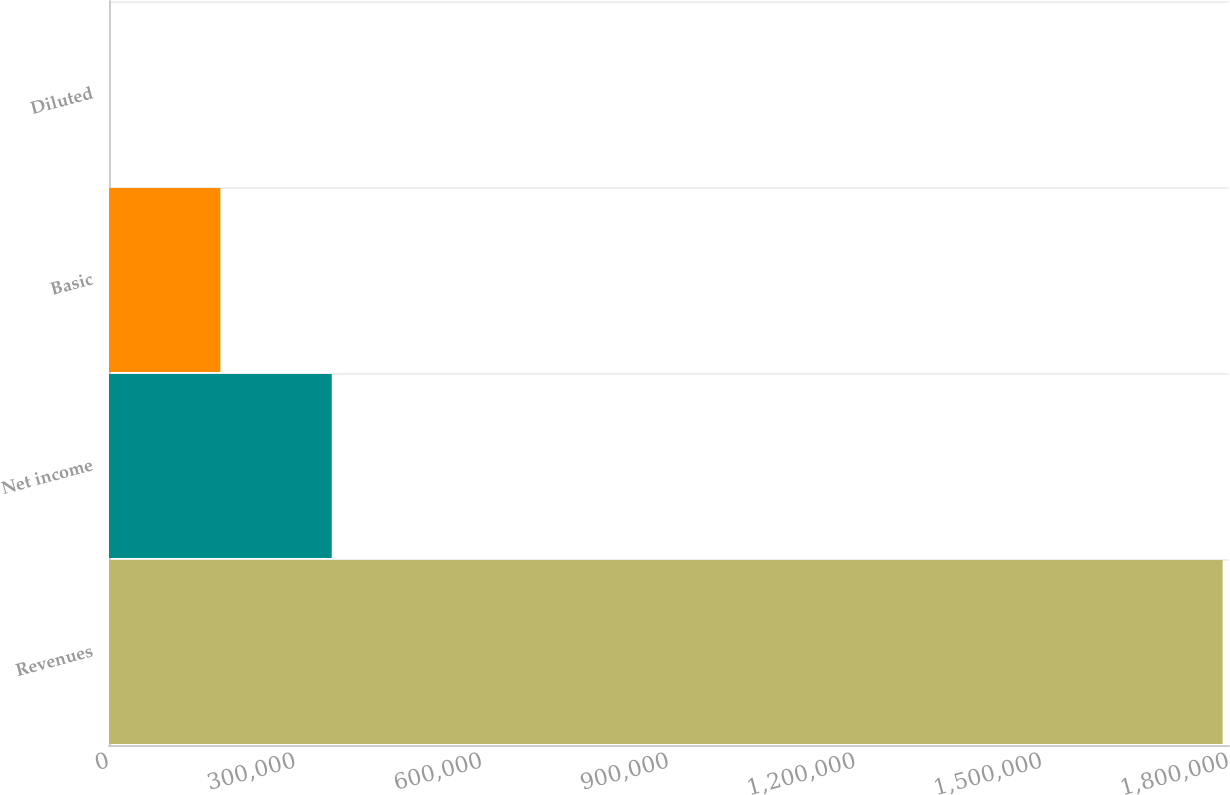<chart> <loc_0><loc_0><loc_500><loc_500><bar_chart><fcel>Revenues<fcel>Net income<fcel>Basic<fcel>Diluted<nl><fcel>1.78976e+06<fcel>357954<fcel>178977<fcel>0.95<nl></chart> 